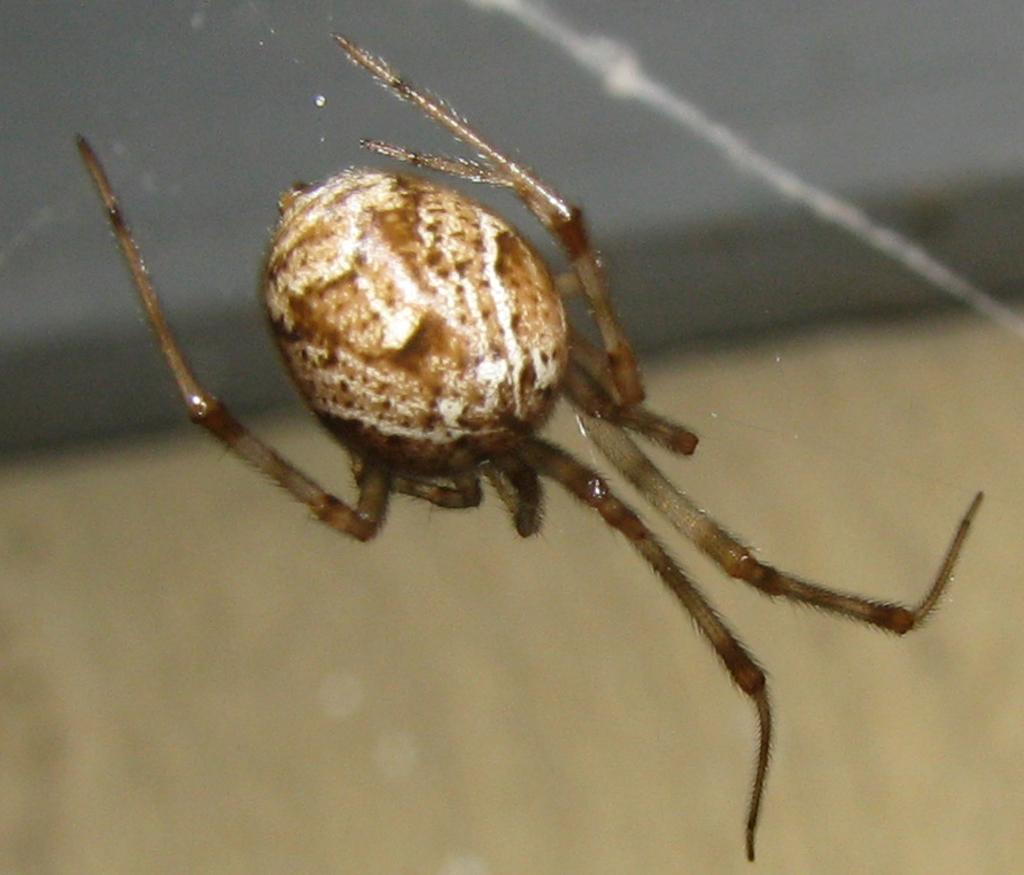What type of creature is in the picture? There is an insect in the picture. Can you describe the insect? The insect looks like a spider. What can be observed about the background of the image? The background of the image is blurred. What type of hose is being used by the spider in the image? There is no hose present in the image; it features an insect that looks like a spider. How does the wren interact with the spider in the image? There is no wren present in the image; it only features an insect that looks like a spider. 